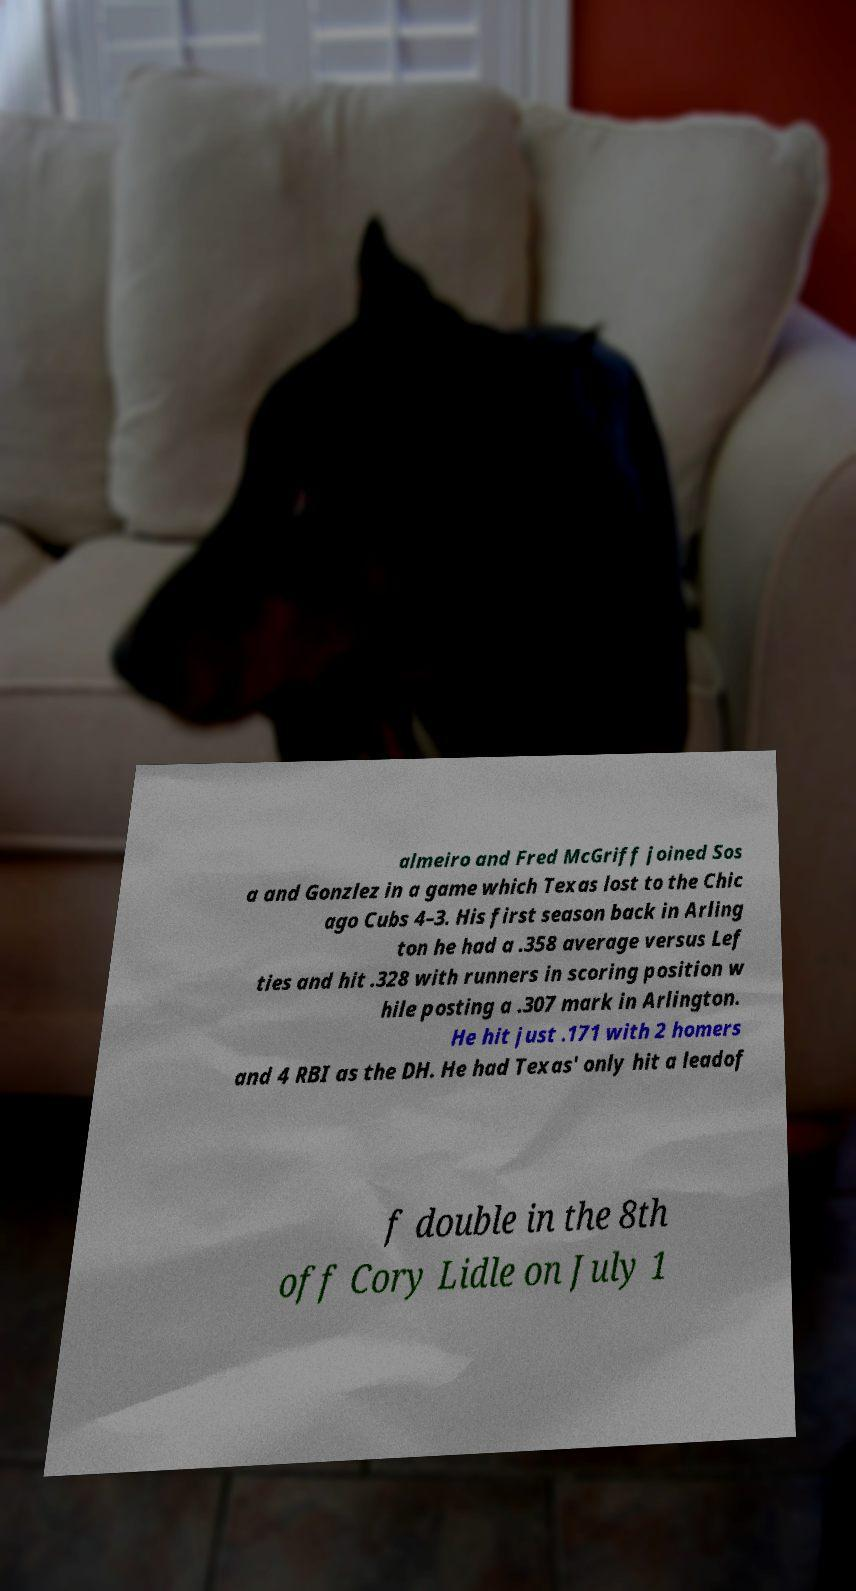Can you accurately transcribe the text from the provided image for me? almeiro and Fred McGriff joined Sos a and Gonzlez in a game which Texas lost to the Chic ago Cubs 4–3. His first season back in Arling ton he had a .358 average versus Lef ties and hit .328 with runners in scoring position w hile posting a .307 mark in Arlington. He hit just .171 with 2 homers and 4 RBI as the DH. He had Texas' only hit a leadof f double in the 8th off Cory Lidle on July 1 